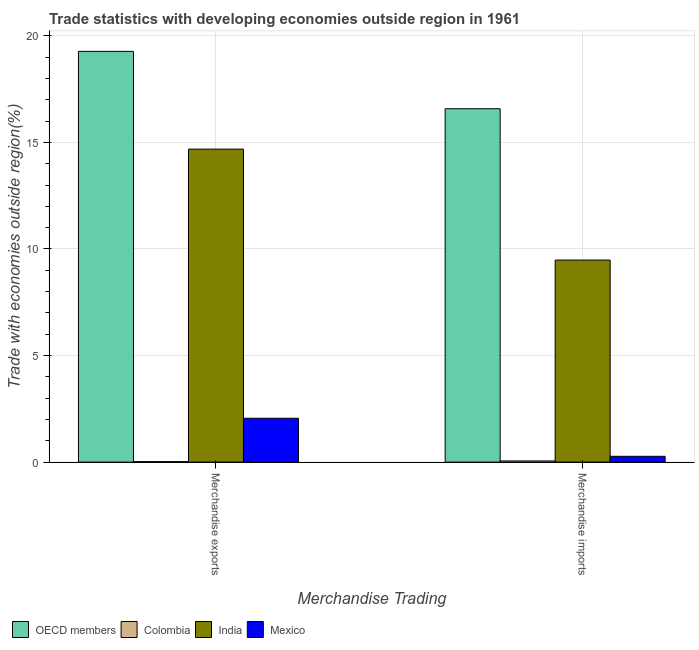How many different coloured bars are there?
Keep it short and to the point. 4. How many groups of bars are there?
Your response must be concise. 2. What is the merchandise exports in OECD members?
Ensure brevity in your answer.  19.27. Across all countries, what is the maximum merchandise imports?
Keep it short and to the point. 16.58. Across all countries, what is the minimum merchandise exports?
Your answer should be compact. 0.02. In which country was the merchandise exports maximum?
Offer a terse response. OECD members. What is the total merchandise exports in the graph?
Offer a very short reply. 36.04. What is the difference between the merchandise imports in OECD members and that in India?
Your answer should be compact. 7.1. What is the difference between the merchandise exports in Colombia and the merchandise imports in Mexico?
Your answer should be very brief. -0.25. What is the average merchandise exports per country?
Your answer should be very brief. 9.01. What is the difference between the merchandise exports and merchandise imports in Mexico?
Ensure brevity in your answer.  1.79. What is the ratio of the merchandise exports in OECD members to that in India?
Ensure brevity in your answer.  1.31. In how many countries, is the merchandise exports greater than the average merchandise exports taken over all countries?
Keep it short and to the point. 2. How many bars are there?
Offer a terse response. 8. Are all the bars in the graph horizontal?
Your answer should be compact. No. How many countries are there in the graph?
Offer a terse response. 4. Does the graph contain any zero values?
Make the answer very short. No. What is the title of the graph?
Your answer should be very brief. Trade statistics with developing economies outside region in 1961. What is the label or title of the X-axis?
Offer a terse response. Merchandise Trading. What is the label or title of the Y-axis?
Offer a very short reply. Trade with economies outside region(%). What is the Trade with economies outside region(%) of OECD members in Merchandise exports?
Offer a terse response. 19.27. What is the Trade with economies outside region(%) in Colombia in Merchandise exports?
Give a very brief answer. 0.02. What is the Trade with economies outside region(%) in India in Merchandise exports?
Your response must be concise. 14.68. What is the Trade with economies outside region(%) in Mexico in Merchandise exports?
Provide a short and direct response. 2.06. What is the Trade with economies outside region(%) of OECD members in Merchandise imports?
Give a very brief answer. 16.58. What is the Trade with economies outside region(%) of Colombia in Merchandise imports?
Offer a terse response. 0.06. What is the Trade with economies outside region(%) of India in Merchandise imports?
Make the answer very short. 9.48. What is the Trade with economies outside region(%) of Mexico in Merchandise imports?
Keep it short and to the point. 0.27. Across all Merchandise Trading, what is the maximum Trade with economies outside region(%) in OECD members?
Provide a succinct answer. 19.27. Across all Merchandise Trading, what is the maximum Trade with economies outside region(%) of Colombia?
Offer a very short reply. 0.06. Across all Merchandise Trading, what is the maximum Trade with economies outside region(%) in India?
Offer a terse response. 14.68. Across all Merchandise Trading, what is the maximum Trade with economies outside region(%) in Mexico?
Your response must be concise. 2.06. Across all Merchandise Trading, what is the minimum Trade with economies outside region(%) in OECD members?
Give a very brief answer. 16.58. Across all Merchandise Trading, what is the minimum Trade with economies outside region(%) in Colombia?
Offer a terse response. 0.02. Across all Merchandise Trading, what is the minimum Trade with economies outside region(%) of India?
Give a very brief answer. 9.48. Across all Merchandise Trading, what is the minimum Trade with economies outside region(%) in Mexico?
Offer a terse response. 0.27. What is the total Trade with economies outside region(%) in OECD members in the graph?
Provide a short and direct response. 35.85. What is the total Trade with economies outside region(%) in Colombia in the graph?
Keep it short and to the point. 0.08. What is the total Trade with economies outside region(%) in India in the graph?
Offer a terse response. 24.16. What is the total Trade with economies outside region(%) of Mexico in the graph?
Offer a terse response. 2.33. What is the difference between the Trade with economies outside region(%) of OECD members in Merchandise exports and that in Merchandise imports?
Keep it short and to the point. 2.69. What is the difference between the Trade with economies outside region(%) in Colombia in Merchandise exports and that in Merchandise imports?
Ensure brevity in your answer.  -0.03. What is the difference between the Trade with economies outside region(%) in India in Merchandise exports and that in Merchandise imports?
Make the answer very short. 5.21. What is the difference between the Trade with economies outside region(%) in Mexico in Merchandise exports and that in Merchandise imports?
Your answer should be compact. 1.79. What is the difference between the Trade with economies outside region(%) in OECD members in Merchandise exports and the Trade with economies outside region(%) in Colombia in Merchandise imports?
Offer a very short reply. 19.22. What is the difference between the Trade with economies outside region(%) in OECD members in Merchandise exports and the Trade with economies outside region(%) in India in Merchandise imports?
Make the answer very short. 9.79. What is the difference between the Trade with economies outside region(%) of OECD members in Merchandise exports and the Trade with economies outside region(%) of Mexico in Merchandise imports?
Your response must be concise. 19. What is the difference between the Trade with economies outside region(%) of Colombia in Merchandise exports and the Trade with economies outside region(%) of India in Merchandise imports?
Provide a succinct answer. -9.46. What is the difference between the Trade with economies outside region(%) in Colombia in Merchandise exports and the Trade with economies outside region(%) in Mexico in Merchandise imports?
Give a very brief answer. -0.25. What is the difference between the Trade with economies outside region(%) in India in Merchandise exports and the Trade with economies outside region(%) in Mexico in Merchandise imports?
Make the answer very short. 14.41. What is the average Trade with economies outside region(%) of OECD members per Merchandise Trading?
Ensure brevity in your answer.  17.93. What is the average Trade with economies outside region(%) of Colombia per Merchandise Trading?
Your answer should be very brief. 0.04. What is the average Trade with economies outside region(%) of India per Merchandise Trading?
Give a very brief answer. 12.08. What is the average Trade with economies outside region(%) of Mexico per Merchandise Trading?
Your answer should be compact. 1.17. What is the difference between the Trade with economies outside region(%) in OECD members and Trade with economies outside region(%) in Colombia in Merchandise exports?
Offer a terse response. 19.25. What is the difference between the Trade with economies outside region(%) of OECD members and Trade with economies outside region(%) of India in Merchandise exports?
Offer a terse response. 4.59. What is the difference between the Trade with economies outside region(%) in OECD members and Trade with economies outside region(%) in Mexico in Merchandise exports?
Offer a very short reply. 17.21. What is the difference between the Trade with economies outside region(%) in Colombia and Trade with economies outside region(%) in India in Merchandise exports?
Provide a succinct answer. -14.66. What is the difference between the Trade with economies outside region(%) of Colombia and Trade with economies outside region(%) of Mexico in Merchandise exports?
Offer a terse response. -2.04. What is the difference between the Trade with economies outside region(%) in India and Trade with economies outside region(%) in Mexico in Merchandise exports?
Offer a very short reply. 12.63. What is the difference between the Trade with economies outside region(%) of OECD members and Trade with economies outside region(%) of Colombia in Merchandise imports?
Offer a terse response. 16.52. What is the difference between the Trade with economies outside region(%) of OECD members and Trade with economies outside region(%) of India in Merchandise imports?
Your answer should be compact. 7.1. What is the difference between the Trade with economies outside region(%) of OECD members and Trade with economies outside region(%) of Mexico in Merchandise imports?
Your response must be concise. 16.31. What is the difference between the Trade with economies outside region(%) in Colombia and Trade with economies outside region(%) in India in Merchandise imports?
Your answer should be very brief. -9.42. What is the difference between the Trade with economies outside region(%) of Colombia and Trade with economies outside region(%) of Mexico in Merchandise imports?
Provide a succinct answer. -0.22. What is the difference between the Trade with economies outside region(%) of India and Trade with economies outside region(%) of Mexico in Merchandise imports?
Offer a very short reply. 9.21. What is the ratio of the Trade with economies outside region(%) in OECD members in Merchandise exports to that in Merchandise imports?
Your answer should be compact. 1.16. What is the ratio of the Trade with economies outside region(%) in Colombia in Merchandise exports to that in Merchandise imports?
Provide a succinct answer. 0.41. What is the ratio of the Trade with economies outside region(%) of India in Merchandise exports to that in Merchandise imports?
Provide a succinct answer. 1.55. What is the ratio of the Trade with economies outside region(%) in Mexico in Merchandise exports to that in Merchandise imports?
Keep it short and to the point. 7.55. What is the difference between the highest and the second highest Trade with economies outside region(%) of OECD members?
Your response must be concise. 2.69. What is the difference between the highest and the second highest Trade with economies outside region(%) in Colombia?
Your answer should be compact. 0.03. What is the difference between the highest and the second highest Trade with economies outside region(%) in India?
Provide a short and direct response. 5.21. What is the difference between the highest and the second highest Trade with economies outside region(%) of Mexico?
Your answer should be compact. 1.79. What is the difference between the highest and the lowest Trade with economies outside region(%) of OECD members?
Provide a succinct answer. 2.69. What is the difference between the highest and the lowest Trade with economies outside region(%) in Colombia?
Your answer should be very brief. 0.03. What is the difference between the highest and the lowest Trade with economies outside region(%) of India?
Your response must be concise. 5.21. What is the difference between the highest and the lowest Trade with economies outside region(%) in Mexico?
Give a very brief answer. 1.79. 